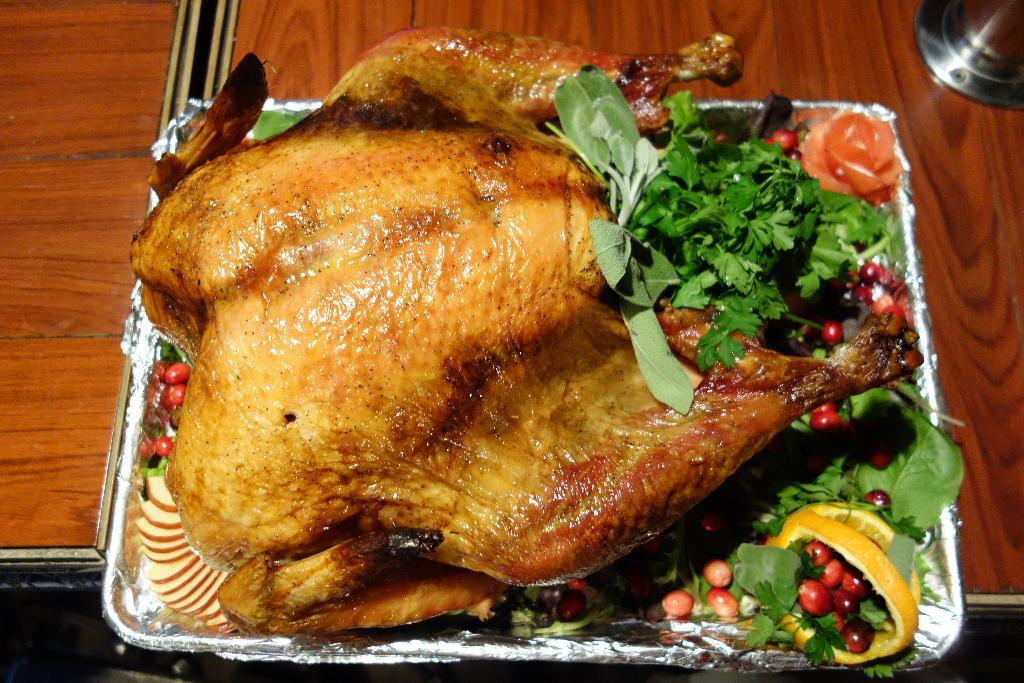What type of bird is in the image? There is a turkey in the image. What other food item can be seen in the image? There is a salad in the image. What else is present in the image besides the turkey and salad? There are other food items in the image. How are the food items arranged in the image? The food items are in a tray. Where is the tray with the food items located? The tray is on a table. What type of comb is used to style the turkey's feathers in the image? There is no comb present in the image, and turkeys do not require styling of their feathers. What type of stove is used to cook the food items in the image? There is no stove present in the image, as the food items are already prepared and arranged in a tray. 